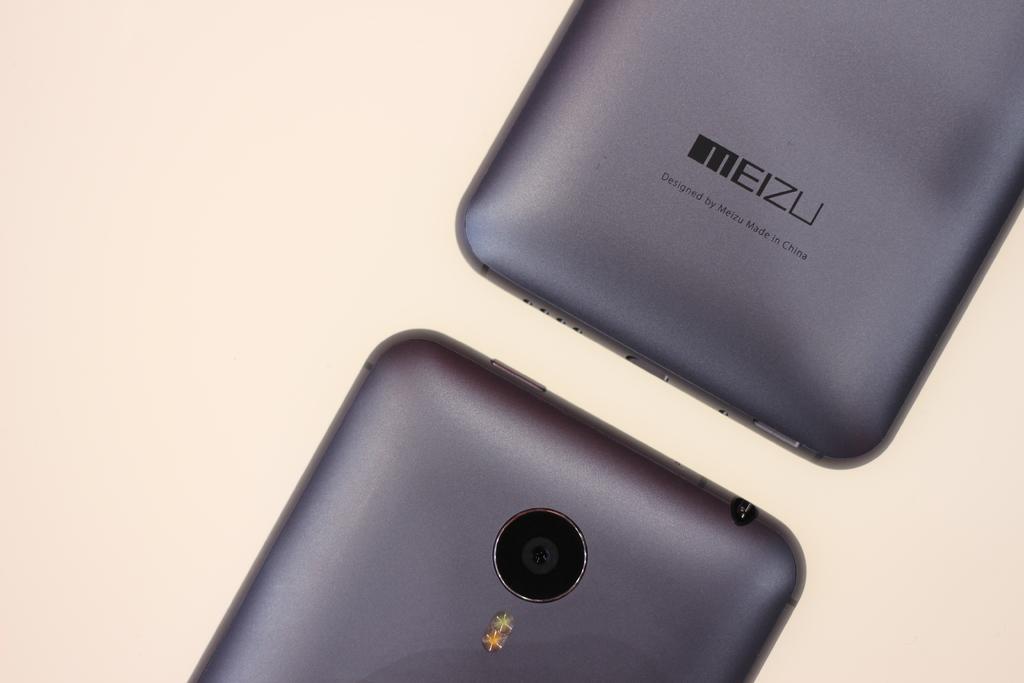What brand of phone is this?
Keep it short and to the point. Meizu. 